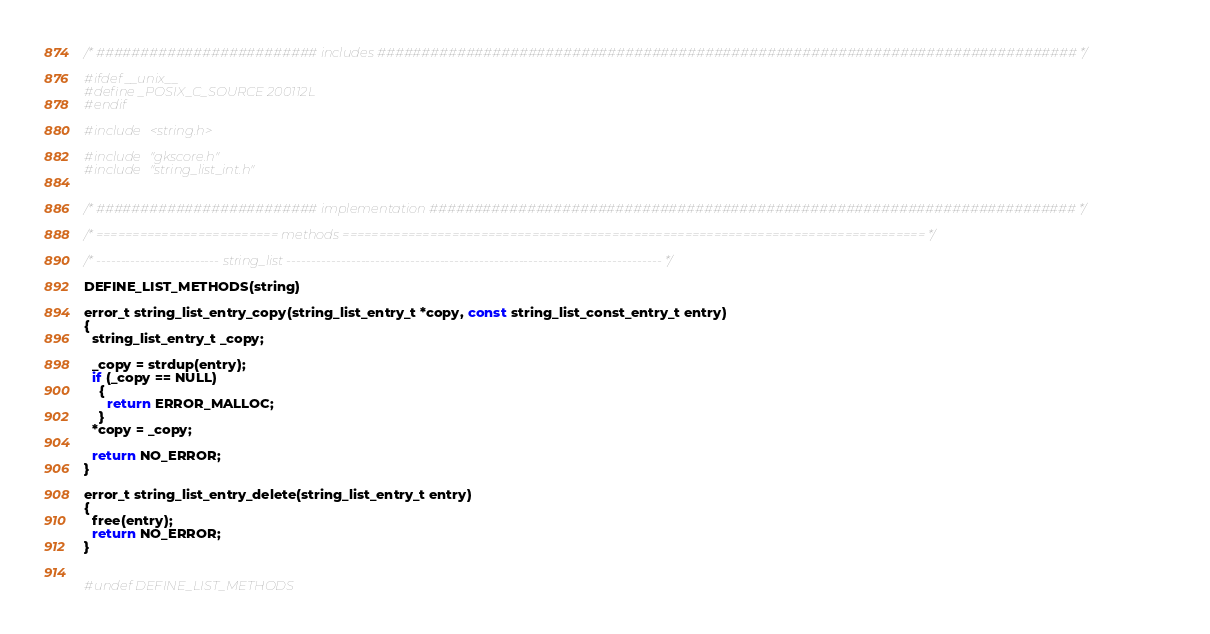<code> <loc_0><loc_0><loc_500><loc_500><_C_>/* ######################### includes ############################################################################### */

#ifdef __unix__
#define _POSIX_C_SOURCE 200112L
#endif

#include <string.h>

#include "gkscore.h"
#include "string_list_int.h"


/* ######################### implementation ######################################################################### */

/* ========================= methods ================================================================================ */

/* ------------------------- string_list ---------------------------------------------------------------------------- */

DEFINE_LIST_METHODS(string)

error_t string_list_entry_copy(string_list_entry_t *copy, const string_list_const_entry_t entry)
{
  string_list_entry_t _copy;

  _copy = strdup(entry);
  if (_copy == NULL)
    {
      return ERROR_MALLOC;
    }
  *copy = _copy;

  return NO_ERROR;
}

error_t string_list_entry_delete(string_list_entry_t entry)
{
  free(entry);
  return NO_ERROR;
}


#undef DEFINE_LIST_METHODS
</code> 